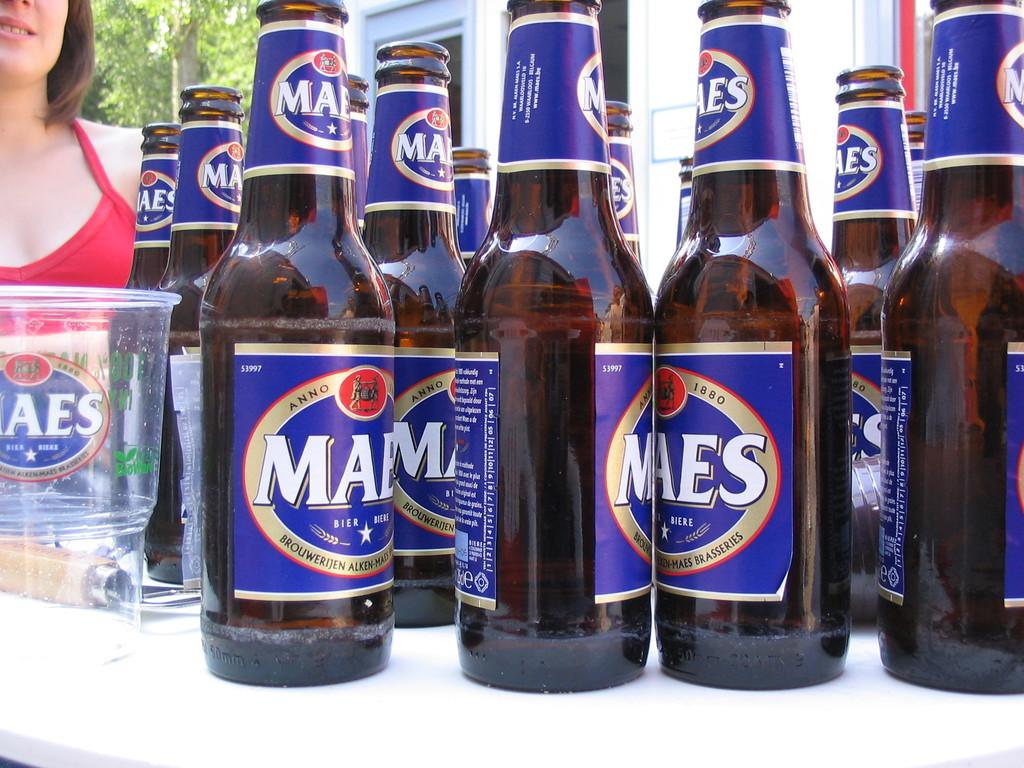What brand of beer is this?
Your answer should be compact. Maes. 